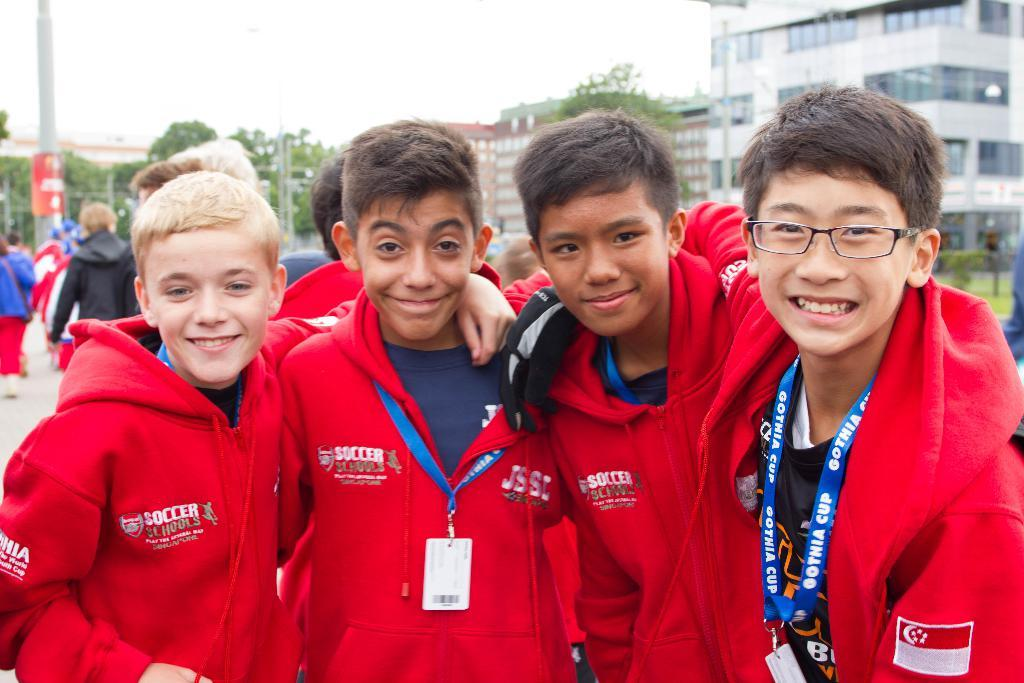How many children are in the image? There are four children in the image. What is the facial expression of the children? The children are smiling. What can be seen in the background of the image? There are trees, poles, buildings, a board, and the sky visible in the background of the image. Are there any other people in the image besides the children? Yes, there are people in the background of the image. What type of vessel is being used by the governor in the image? There is no governor or vessel present in the image. 